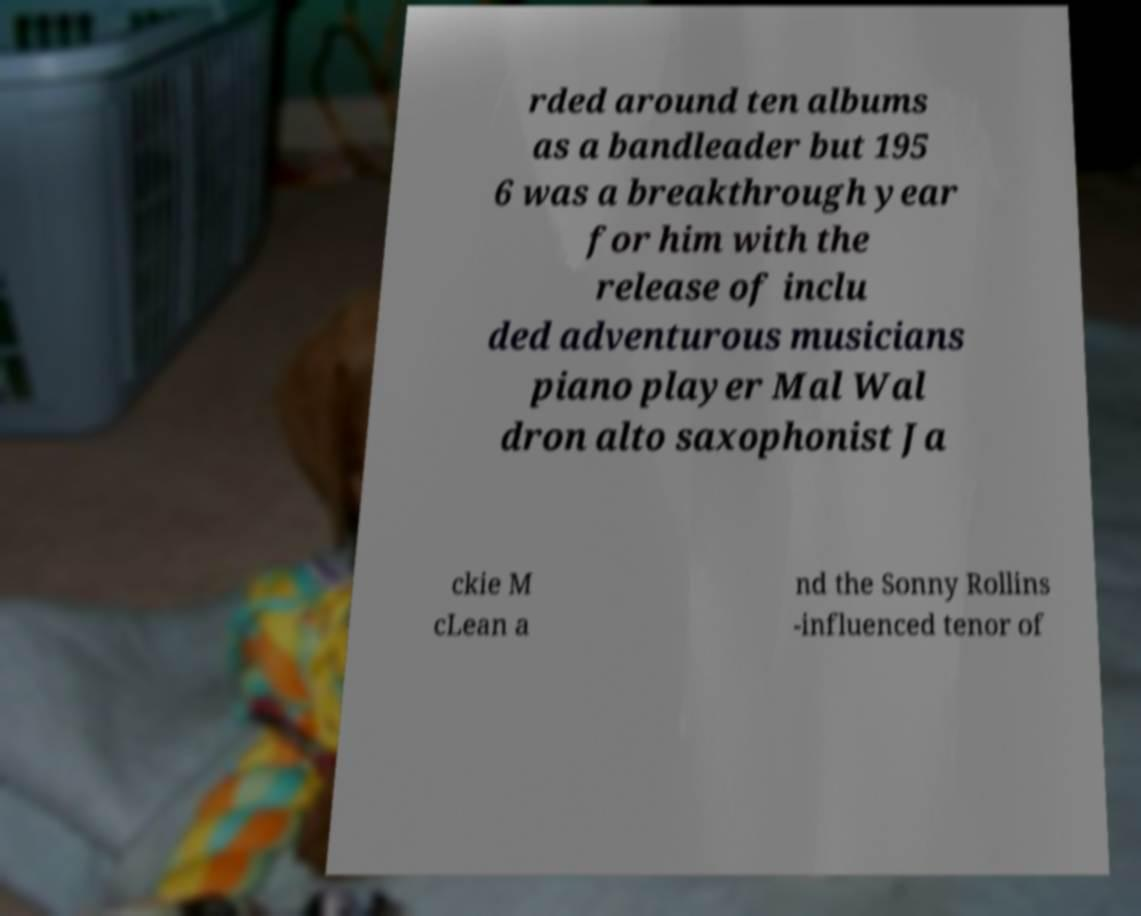Please identify and transcribe the text found in this image. rded around ten albums as a bandleader but 195 6 was a breakthrough year for him with the release of inclu ded adventurous musicians piano player Mal Wal dron alto saxophonist Ja ckie M cLean a nd the Sonny Rollins -influenced tenor of 